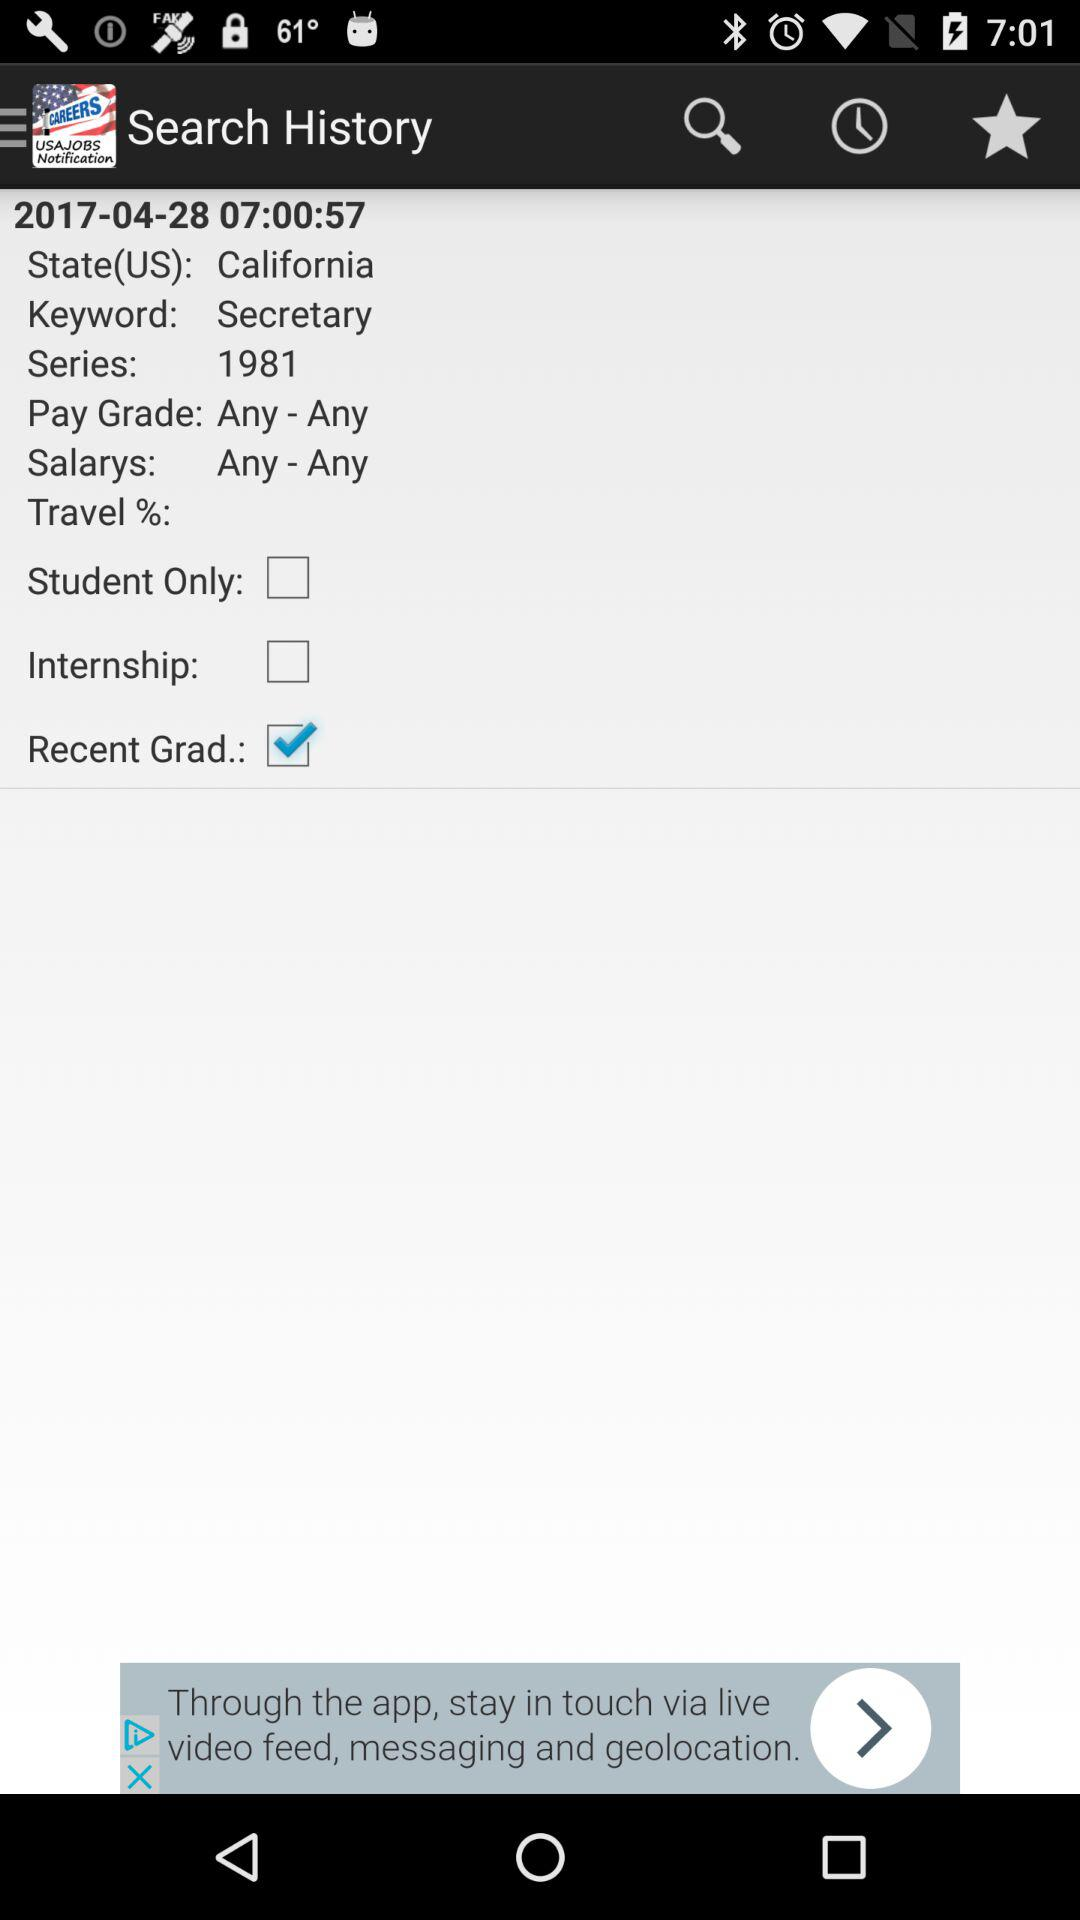What's the "Pay Grade"? The Pay Grade is "Any - Any". 